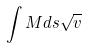<formula> <loc_0><loc_0><loc_500><loc_500>\int M d s \sqrt { v }</formula> 